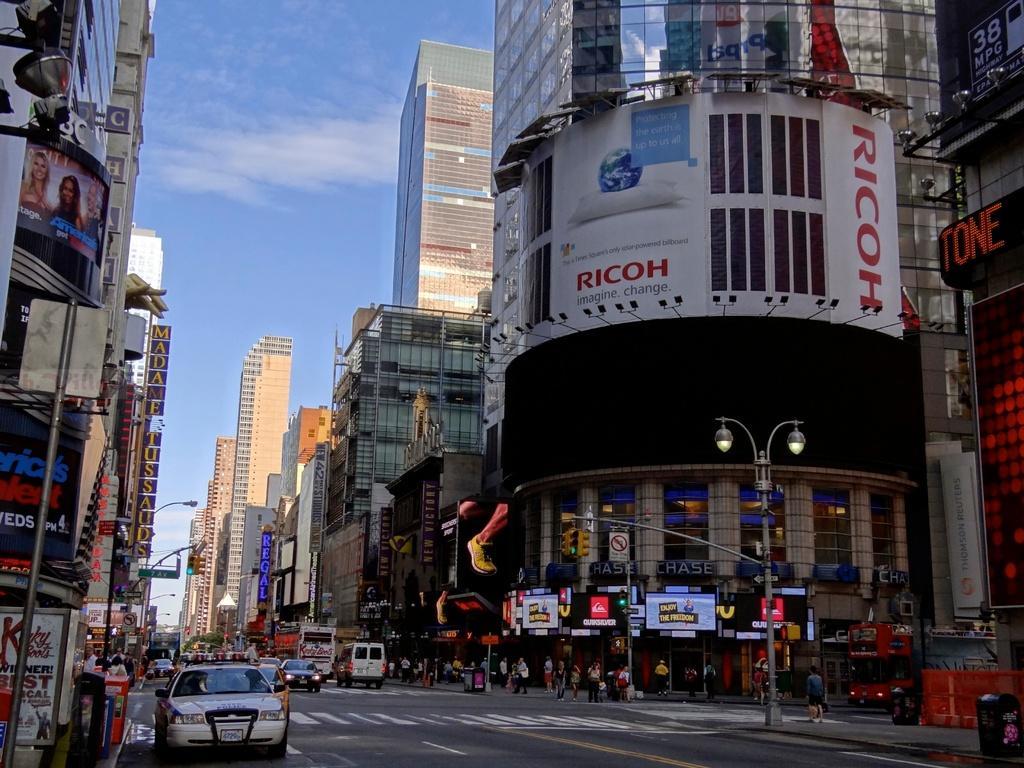How would you summarize this image in a sentence or two? In the center of the image there are cars on the road. There are people walking on the road. On both right and left side of the image there are buildings, dustbins, street lights. In the background of the image there is sky. 